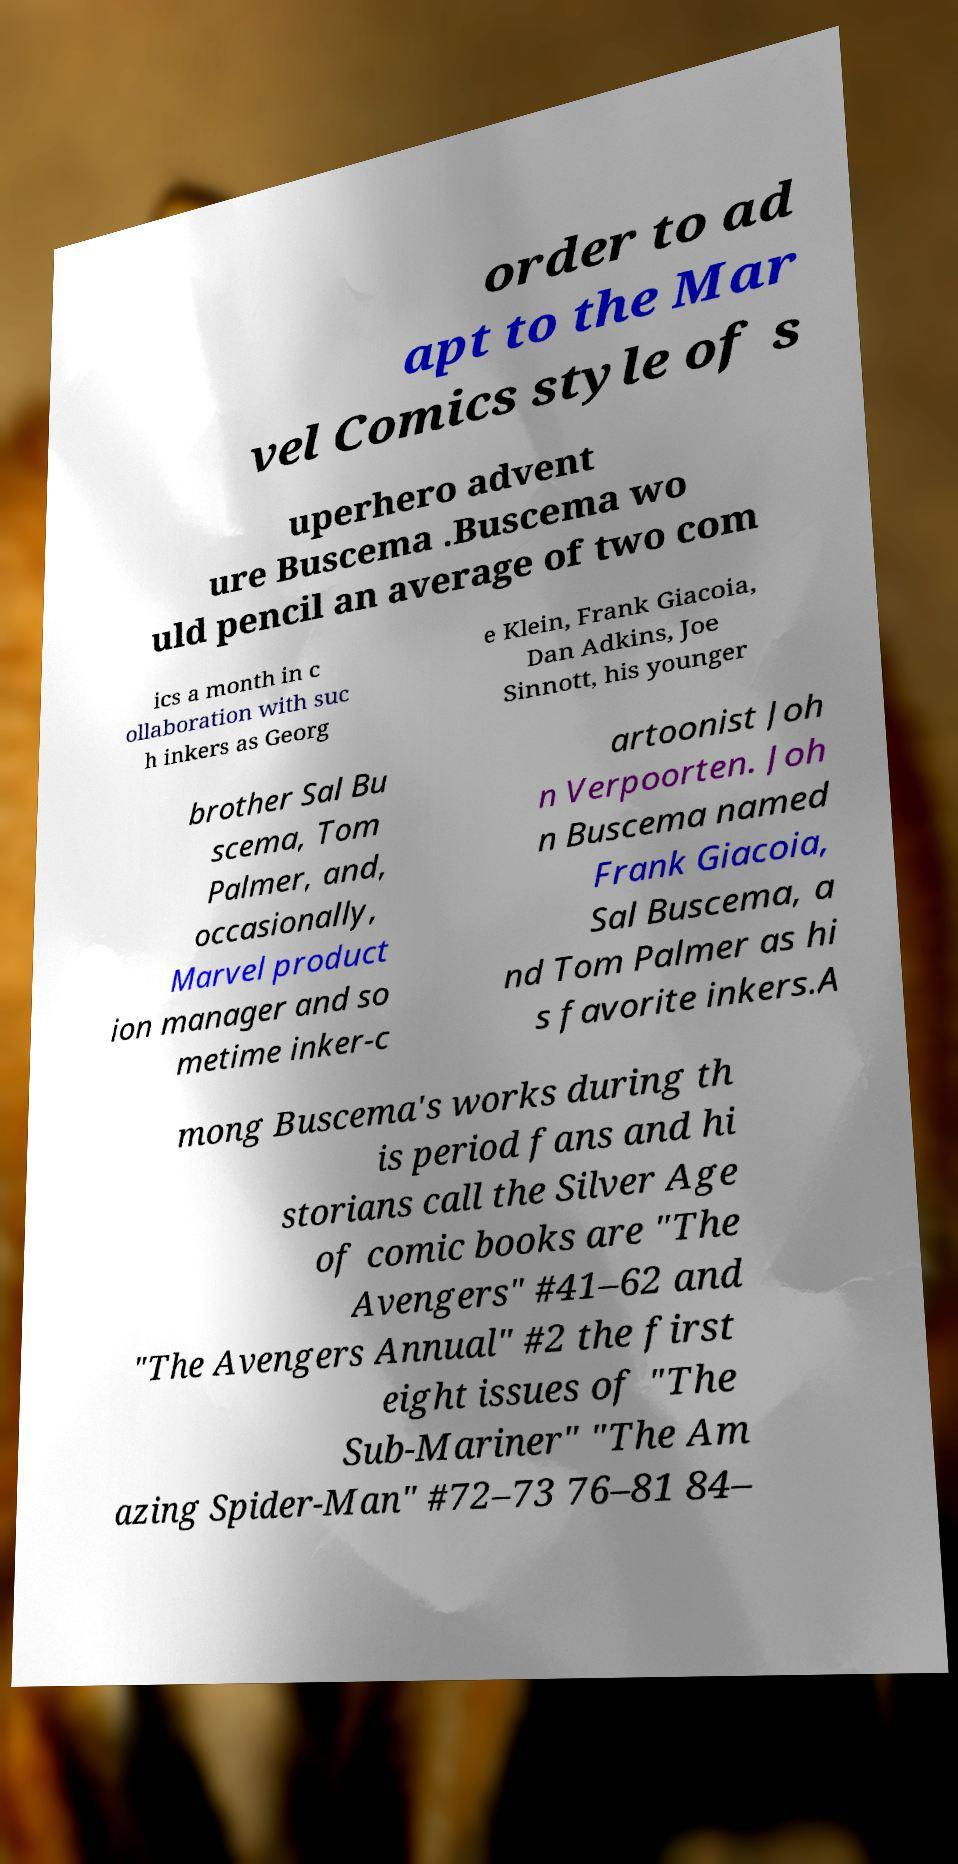Please identify and transcribe the text found in this image. order to ad apt to the Mar vel Comics style of s uperhero advent ure Buscema .Buscema wo uld pencil an average of two com ics a month in c ollaboration with suc h inkers as Georg e Klein, Frank Giacoia, Dan Adkins, Joe Sinnott, his younger brother Sal Bu scema, Tom Palmer, and, occasionally, Marvel product ion manager and so metime inker-c artoonist Joh n Verpoorten. Joh n Buscema named Frank Giacoia, Sal Buscema, a nd Tom Palmer as hi s favorite inkers.A mong Buscema's works during th is period fans and hi storians call the Silver Age of comic books are "The Avengers" #41–62 and "The Avengers Annual" #2 the first eight issues of "The Sub-Mariner" "The Am azing Spider-Man" #72–73 76–81 84– 